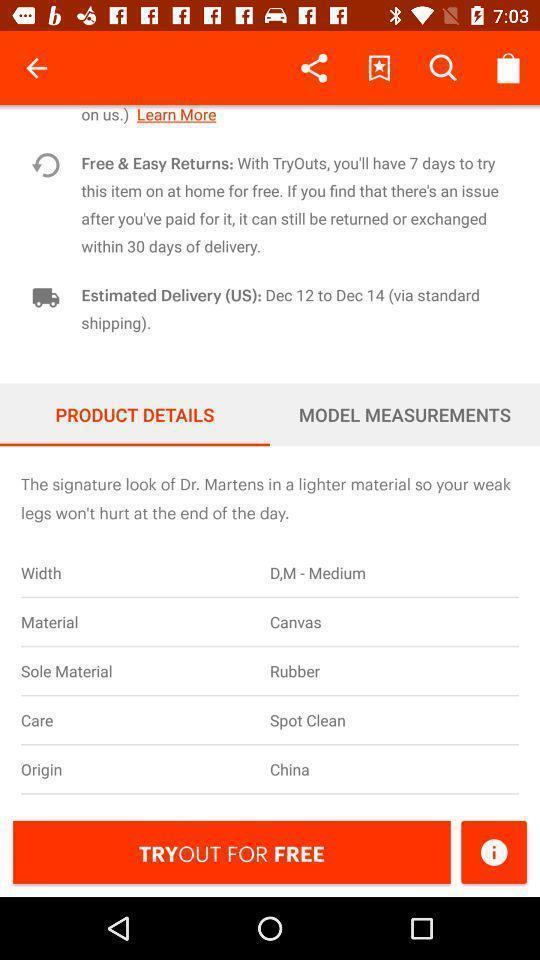Describe the visual elements of this screenshot. Pop-up showing product details in a shopping app. 